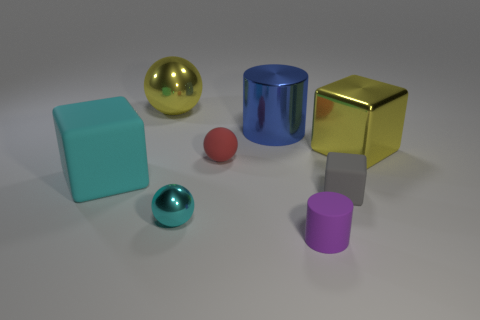How many other things are there of the same shape as the small red object?
Ensure brevity in your answer.  2. What is the shape of the big yellow object that is in front of the blue cylinder?
Offer a very short reply. Cube. There is a small cyan metal object; is it the same shape as the large yellow thing on the left side of the small red object?
Offer a very short reply. Yes. There is a object that is behind the tiny red object and to the left of the small metal object; how big is it?
Make the answer very short. Large. There is a big metal object that is both in front of the yellow metallic ball and on the left side of the tiny purple cylinder; what color is it?
Provide a succinct answer. Blue. Are there fewer blue cylinders in front of the tiny matte cylinder than red spheres to the left of the small block?
Ensure brevity in your answer.  Yes. Is there any other thing of the same color as the big metal cylinder?
Make the answer very short. No. The cyan rubber object is what shape?
Offer a terse response. Cube. There is a large block that is made of the same material as the blue cylinder; what color is it?
Provide a short and direct response. Yellow. Is the number of big red metal cylinders greater than the number of yellow spheres?
Offer a very short reply. No. 